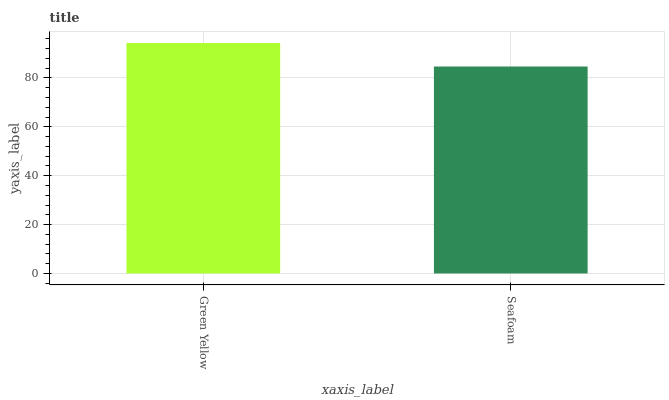Is Seafoam the maximum?
Answer yes or no. No. Is Green Yellow greater than Seafoam?
Answer yes or no. Yes. Is Seafoam less than Green Yellow?
Answer yes or no. Yes. Is Seafoam greater than Green Yellow?
Answer yes or no. No. Is Green Yellow less than Seafoam?
Answer yes or no. No. Is Green Yellow the high median?
Answer yes or no. Yes. Is Seafoam the low median?
Answer yes or no. Yes. Is Seafoam the high median?
Answer yes or no. No. Is Green Yellow the low median?
Answer yes or no. No. 